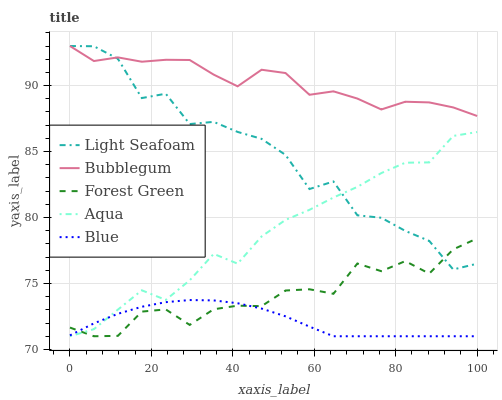Does Blue have the minimum area under the curve?
Answer yes or no. Yes. Does Bubblegum have the maximum area under the curve?
Answer yes or no. Yes. Does Forest Green have the minimum area under the curve?
Answer yes or no. No. Does Forest Green have the maximum area under the curve?
Answer yes or no. No. Is Blue the smoothest?
Answer yes or no. Yes. Is Light Seafoam the roughest?
Answer yes or no. Yes. Is Forest Green the smoothest?
Answer yes or no. No. Is Forest Green the roughest?
Answer yes or no. No. Does Light Seafoam have the lowest value?
Answer yes or no. No. Does Bubblegum have the highest value?
Answer yes or no. Yes. Does Forest Green have the highest value?
Answer yes or no. No. Is Blue less than Bubblegum?
Answer yes or no. Yes. Is Bubblegum greater than Blue?
Answer yes or no. Yes. Does Light Seafoam intersect Aqua?
Answer yes or no. Yes. Is Light Seafoam less than Aqua?
Answer yes or no. No. Is Light Seafoam greater than Aqua?
Answer yes or no. No. Does Blue intersect Bubblegum?
Answer yes or no. No. 